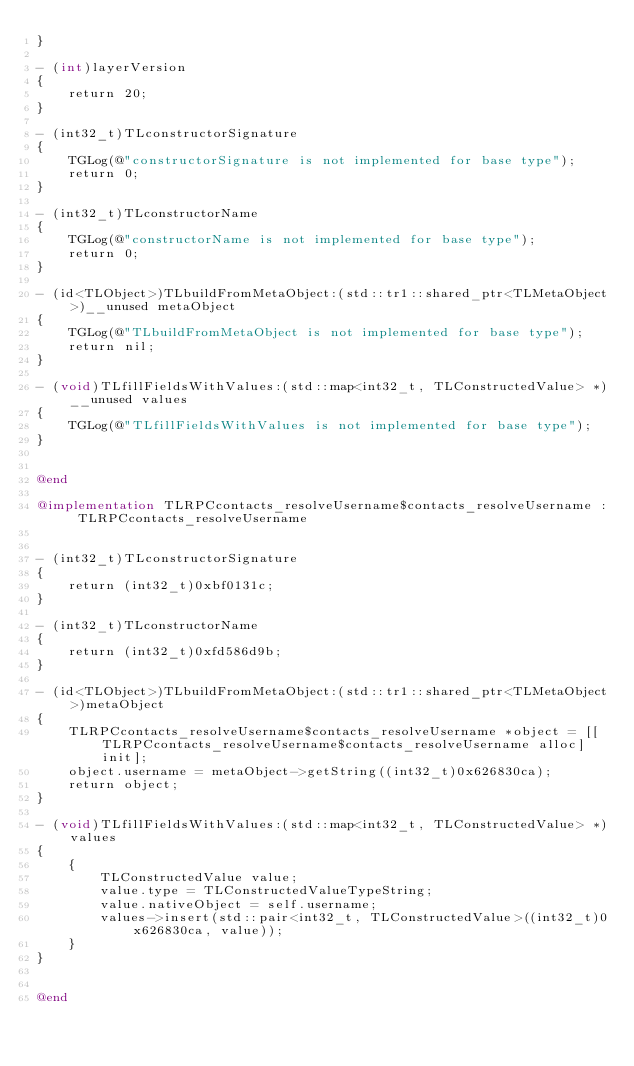Convert code to text. <code><loc_0><loc_0><loc_500><loc_500><_ObjectiveC_>}

- (int)layerVersion
{
    return 20;
}

- (int32_t)TLconstructorSignature
{
    TGLog(@"constructorSignature is not implemented for base type");
    return 0;
}

- (int32_t)TLconstructorName
{
    TGLog(@"constructorName is not implemented for base type");
    return 0;
}

- (id<TLObject>)TLbuildFromMetaObject:(std::tr1::shared_ptr<TLMetaObject>)__unused metaObject
{
    TGLog(@"TLbuildFromMetaObject is not implemented for base type");
    return nil;
}

- (void)TLfillFieldsWithValues:(std::map<int32_t, TLConstructedValue> *)__unused values
{
    TGLog(@"TLfillFieldsWithValues is not implemented for base type");
}


@end

@implementation TLRPCcontacts_resolveUsername$contacts_resolveUsername : TLRPCcontacts_resolveUsername


- (int32_t)TLconstructorSignature
{
    return (int32_t)0xbf0131c;
}

- (int32_t)TLconstructorName
{
    return (int32_t)0xfd586d9b;
}

- (id<TLObject>)TLbuildFromMetaObject:(std::tr1::shared_ptr<TLMetaObject>)metaObject
{
    TLRPCcontacts_resolveUsername$contacts_resolveUsername *object = [[TLRPCcontacts_resolveUsername$contacts_resolveUsername alloc] init];
    object.username = metaObject->getString((int32_t)0x626830ca);
    return object;
}

- (void)TLfillFieldsWithValues:(std::map<int32_t, TLConstructedValue> *)values
{
    {
        TLConstructedValue value;
        value.type = TLConstructedValueTypeString;
        value.nativeObject = self.username;
        values->insert(std::pair<int32_t, TLConstructedValue>((int32_t)0x626830ca, value));
    }
}


@end

</code> 